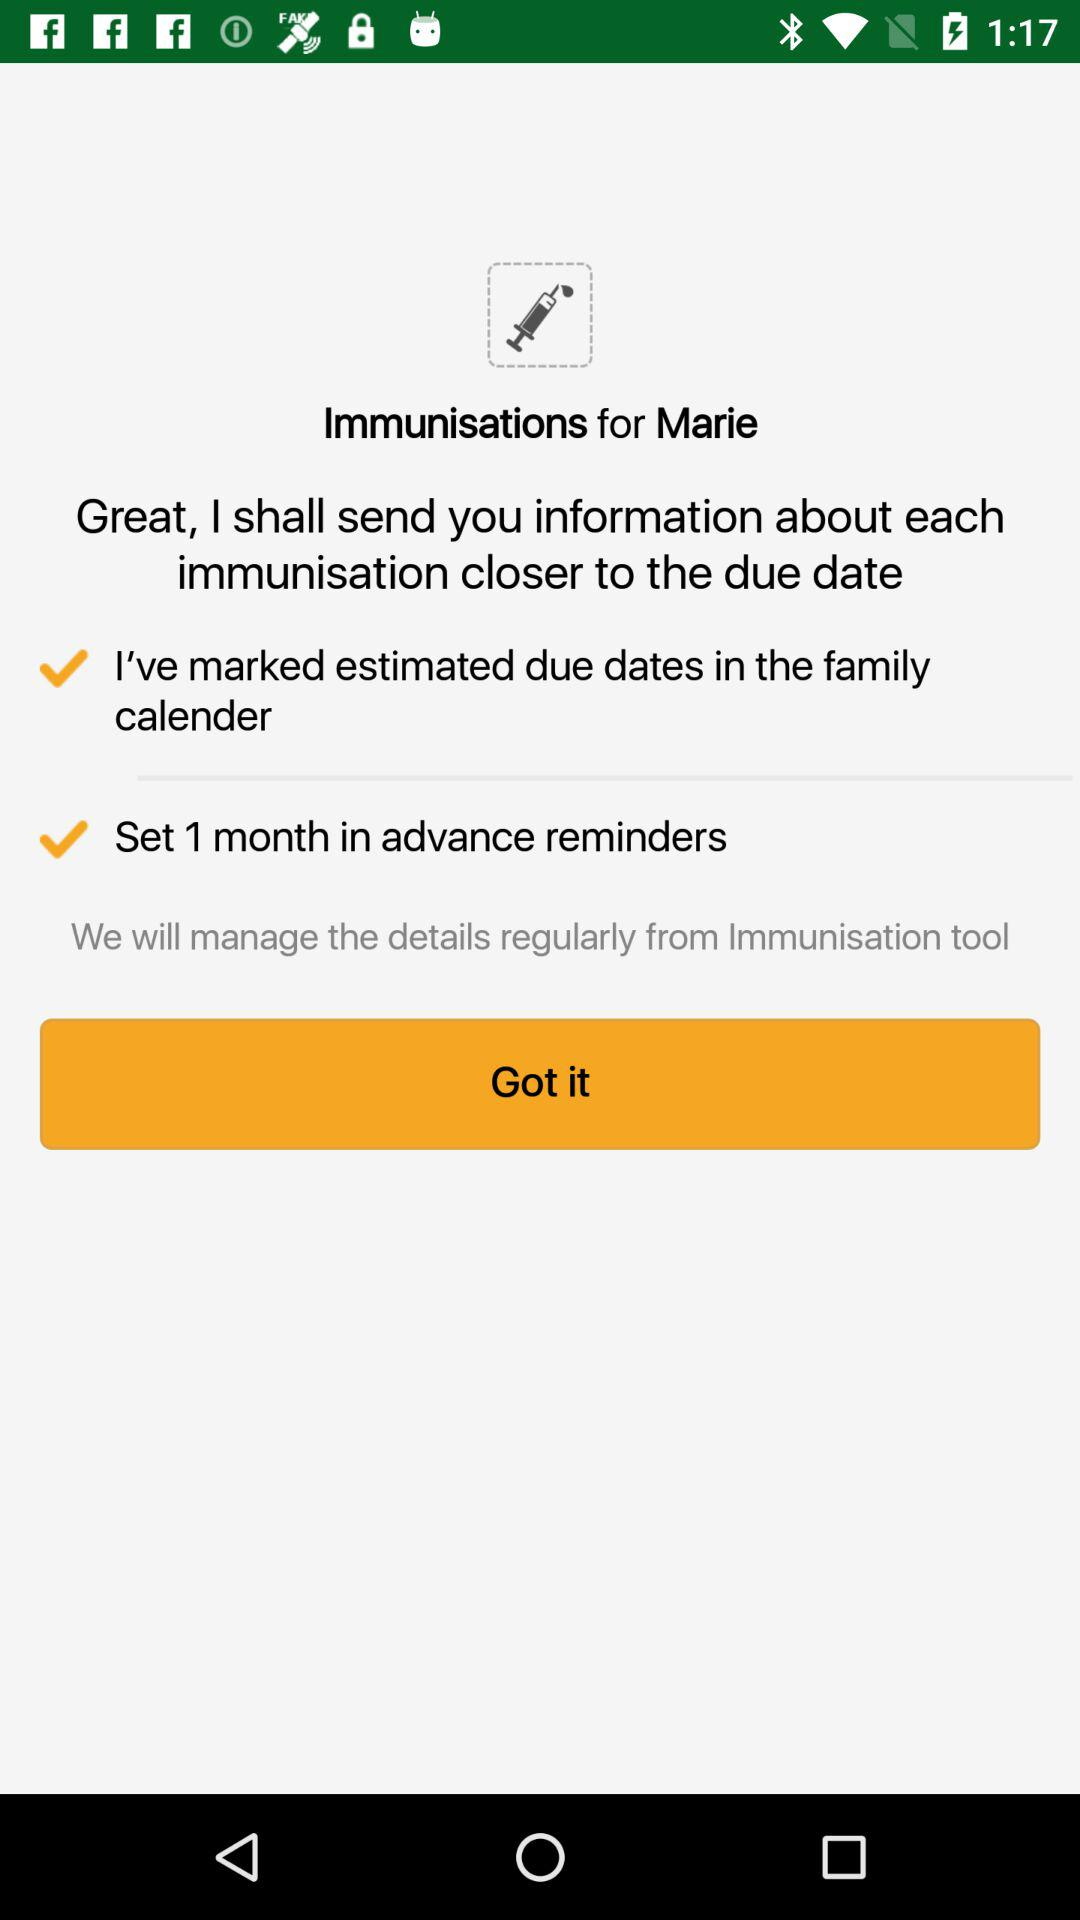How many days before the due date are reminders set for?
Answer the question using a single word or phrase. 1 month 